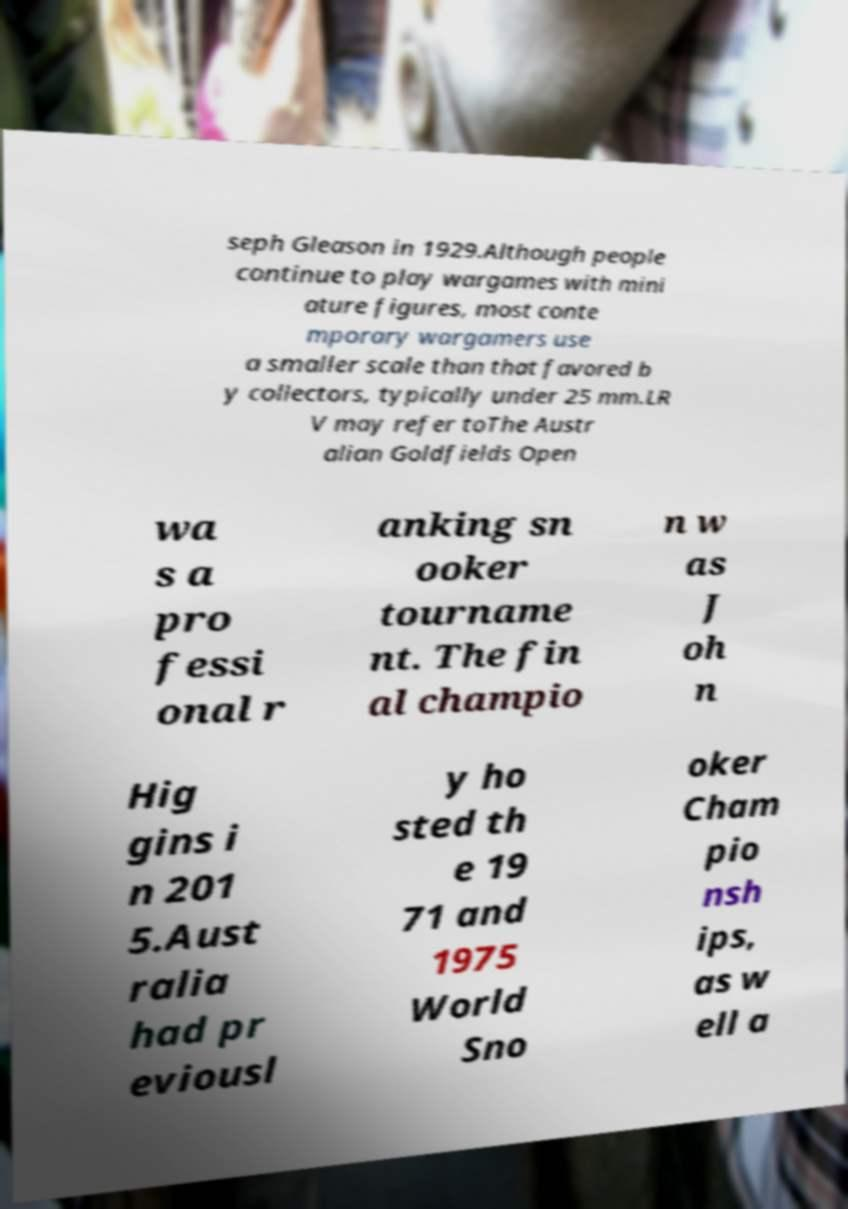Please read and relay the text visible in this image. What does it say? seph Gleason in 1929.Although people continue to play wargames with mini ature figures, most conte mporary wargamers use a smaller scale than that favored b y collectors, typically under 25 mm.LR V may refer toThe Austr alian Goldfields Open wa s a pro fessi onal r anking sn ooker tourname nt. The fin al champio n w as J oh n Hig gins i n 201 5.Aust ralia had pr eviousl y ho sted th e 19 71 and 1975 World Sno oker Cham pio nsh ips, as w ell a 